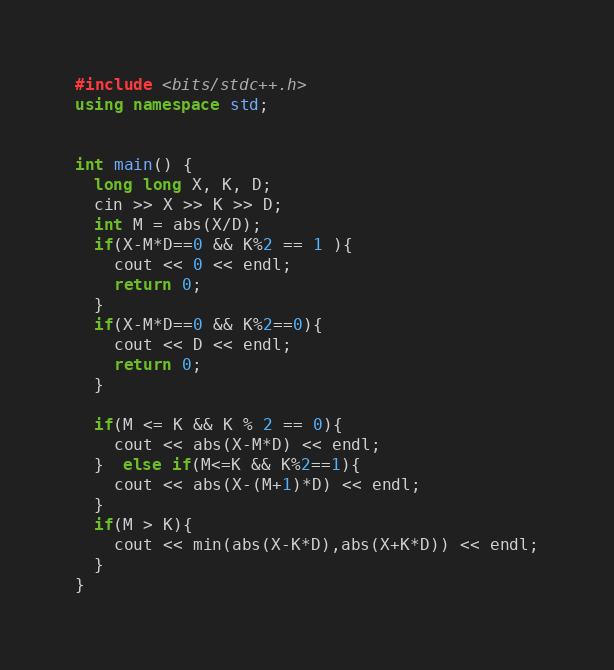<code> <loc_0><loc_0><loc_500><loc_500><_C++_>#include <bits/stdc++.h>
using namespace std;


int main() {
  long long X, K, D;
  cin >> X >> K >> D;
  int M = abs(X/D);
  if(X-M*D==0 && K%2 == 1 ){
    cout << 0 << endl;
    return 0;
  }
  if(X-M*D==0 && K%2==0){
    cout << D << endl;
    return 0;
  }
  
  if(M <= K && K % 2 == 0){
    cout << abs(X-M*D) << endl;
  }  else if(M<=K && K%2==1){
    cout << abs(X-(M+1)*D) << endl;
  }
  if(M > K){
    cout << min(abs(X-K*D),abs(X+K*D)) << endl;
  }
}
</code> 